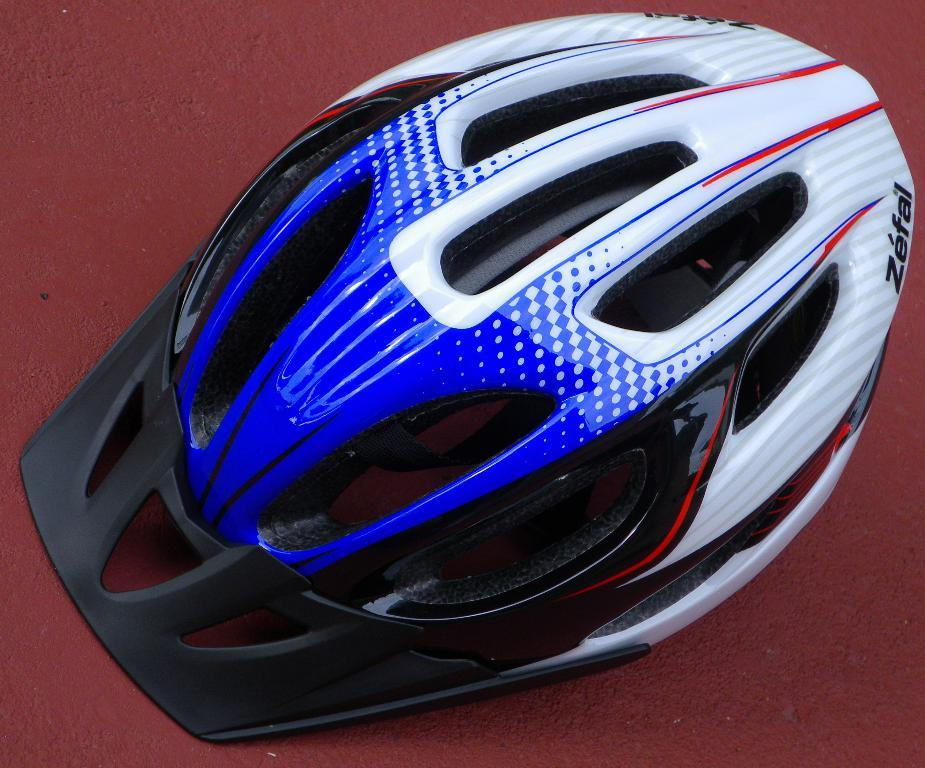What object is placed on the floor in the image? There is a helmet on the floor. How many people are wearing the helmet in the image? There is no person wearing the helmet in the image, as it is placed on the floor. What type of cars can be seen in the image? There are no cars present in the image. Is there an arm visible in the image? There is no arm visible in the image; only the helmet on the floor is present. 